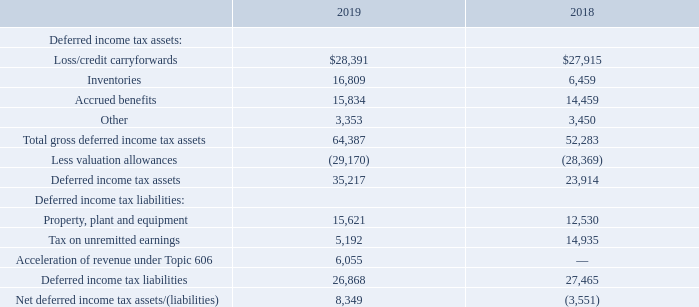The components of the net deferred income tax assets as of September 28, 2019 and September 29, 2018, were as follows (in thousands):
During fiscal 2019, the Company’s valuation allowance increased by $0.8 million. This increase is the result of increases to the valuation allowances against the net deferred tax assets in the AMER region of $1.7 million, partially offset by a decrease in net deferred tax assets in the EMEA region of $0.9 million.
As of September 28, 2019, the Company had approximately $189.2 million of pre-tax state net operating loss carryforwards that expire between fiscal 2020 and 2040. Certain state net operating losses have a full valuation allowance against them. The Company also had approximately $79.6 million of pre-tax foreign net operating loss carryforwards that expire between fiscal 2019 and 2025 or are indefinitely carried forward. These foreign net operating losses have a full valuation allowance against them.
During fiscal 2019, proposed and final regulations were issued and tax legislation was adopted in various jurisdictions. The impacts of these regulations and legislation on the Company’s consolidated financial condition, results of operations and cash flows are included above.
The Company has been granted a tax holiday for a foreign subsidiary in the APAC segment. This tax holiday will expire onD ecember 31, 2024, and is subject to certain conditions with which the Company expects to continue to comply. During fiscal 2019, 2018 and 2017, the tax holiday resulted in tax reductions of approximately $23.9 million net of the impact of the GILTI provisions of Tax Reform ($0.79 per basic share, $0.77 per diluted share), $39.1 million ($1.19 per basic share, $1.15 per diluted share) and $37.5 million ($1.11 per basic share, $1.08 per diluted share), respectively.
The Company does not provide for taxes that would be payable if certain undistributed earnings of foreign subsidiaries were remitted because the Company considers these earnings to be permanently reinvested. The deferred tax liability that has not been recorded for these earnings was approximately $10.5 million as of September 28, 2019.
The Company has approximately $2.3 million of uncertain tax benefits as of September 28, 2019. The Company has classified these amounts in the Consolidated Balance Sheets as "Other liabilities" (noncurrent) in the amount of $1.5 million and an offset to "Deferred income taxes" (noncurrent asset) in the amount of $0.8 million. The Company has classified these amounts as "Other liabilities" (noncurrent) and "Deferred income taxes" (noncurrent asset) to the extent that payment is not anticipated within one year.
What was the change in the company's valuation allowance during Fiscal 2019?
Answer scale should be: million. 0.8. What was the amount of inventories in 2018?
Answer scale should be: thousand. 6,459. What was the amount of Accrued benefits in 2019?
Answer scale should be: thousand. 15,834. How many years did the Loss/credit carryforwards exceed $25,000 thousand? 2019##2018
Answer: 2. What was the change in the inventories between 2018 and 2019?
Answer scale should be: thousand. 16,809-6,459
Answer: 10350. What was the percentage change in the Property, plant and equipment between 2018 and 2019?
Answer scale should be: percent. (15,621-12,530)/12,530
Answer: 24.67. 